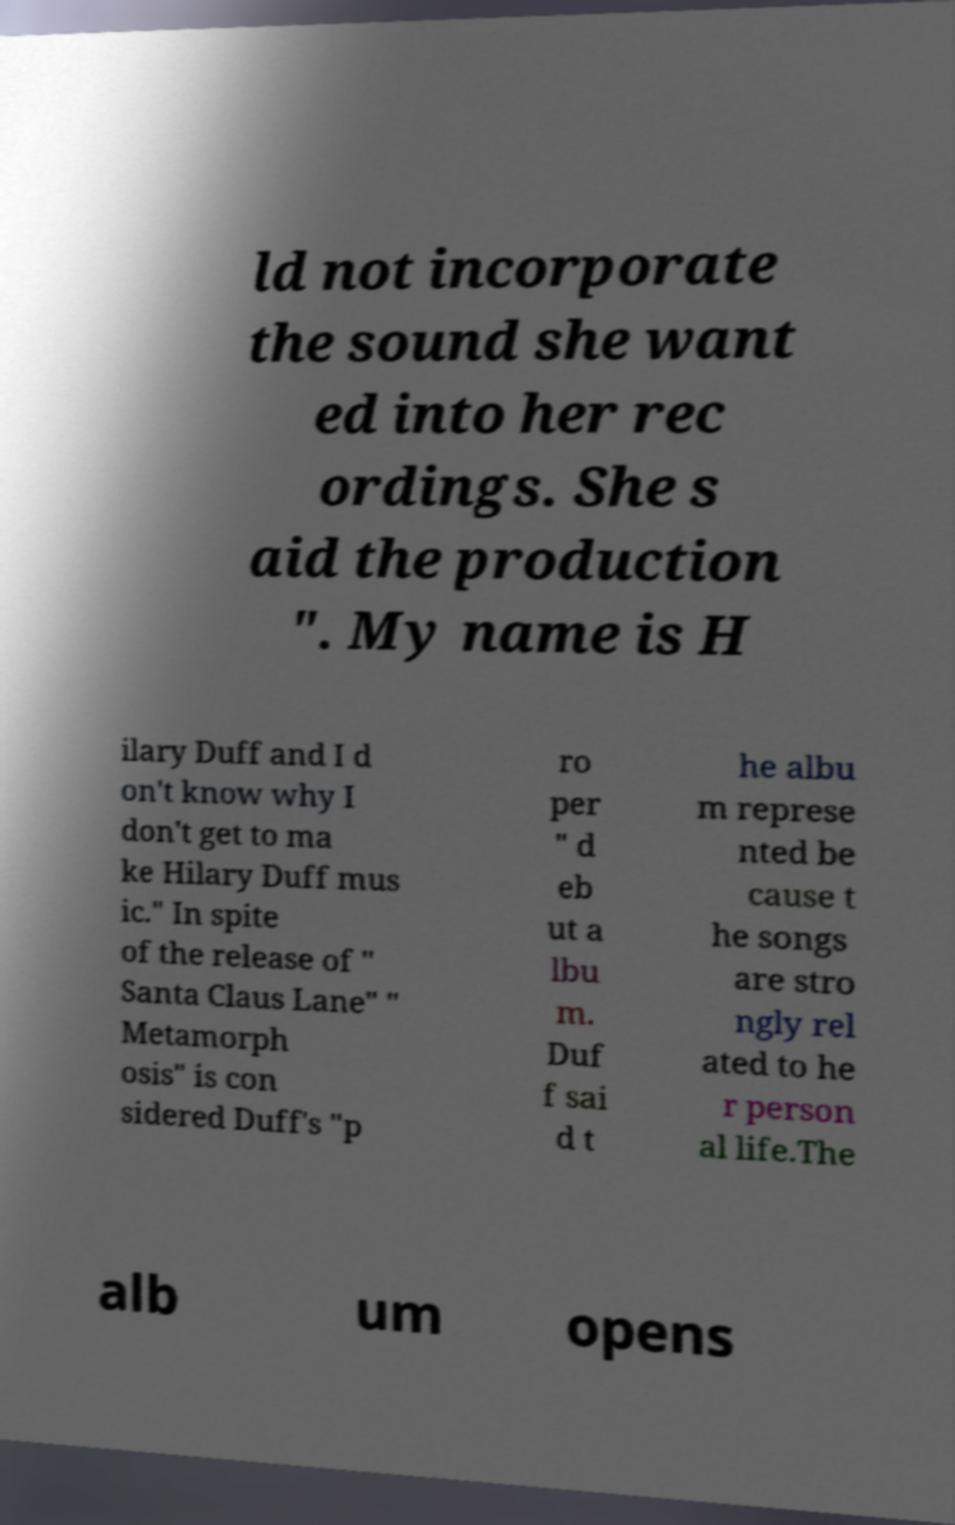For documentation purposes, I need the text within this image transcribed. Could you provide that? ld not incorporate the sound she want ed into her rec ordings. She s aid the production ". My name is H ilary Duff and I d on't know why I don't get to ma ke Hilary Duff mus ic." In spite of the release of " Santa Claus Lane" " Metamorph osis" is con sidered Duff's "p ro per " d eb ut a lbu m. Duf f sai d t he albu m represe nted be cause t he songs are stro ngly rel ated to he r person al life.The alb um opens 